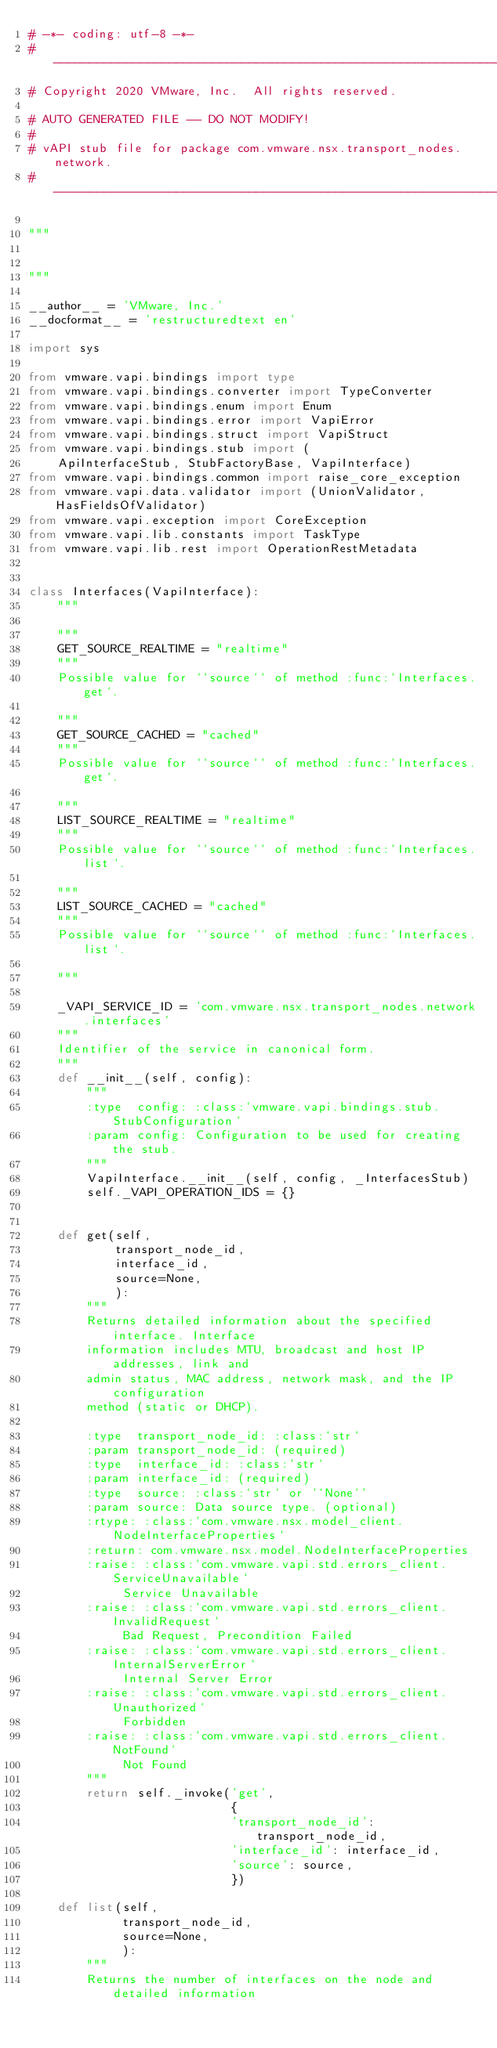<code> <loc_0><loc_0><loc_500><loc_500><_Python_># -*- coding: utf-8 -*-
#---------------------------------------------------------------------------
# Copyright 2020 VMware, Inc.  All rights reserved.

# AUTO GENERATED FILE -- DO NOT MODIFY!
#
# vAPI stub file for package com.vmware.nsx.transport_nodes.network.
#---------------------------------------------------------------------------

"""


"""

__author__ = 'VMware, Inc.'
__docformat__ = 'restructuredtext en'

import sys

from vmware.vapi.bindings import type
from vmware.vapi.bindings.converter import TypeConverter
from vmware.vapi.bindings.enum import Enum
from vmware.vapi.bindings.error import VapiError
from vmware.vapi.bindings.struct import VapiStruct
from vmware.vapi.bindings.stub import (
    ApiInterfaceStub, StubFactoryBase, VapiInterface)
from vmware.vapi.bindings.common import raise_core_exception
from vmware.vapi.data.validator import (UnionValidator, HasFieldsOfValidator)
from vmware.vapi.exception import CoreException
from vmware.vapi.lib.constants import TaskType
from vmware.vapi.lib.rest import OperationRestMetadata


class Interfaces(VapiInterface):
    """
    
    """
    GET_SOURCE_REALTIME = "realtime"
    """
    Possible value for ``source`` of method :func:`Interfaces.get`.

    """
    GET_SOURCE_CACHED = "cached"
    """
    Possible value for ``source`` of method :func:`Interfaces.get`.

    """
    LIST_SOURCE_REALTIME = "realtime"
    """
    Possible value for ``source`` of method :func:`Interfaces.list`.

    """
    LIST_SOURCE_CACHED = "cached"
    """
    Possible value for ``source`` of method :func:`Interfaces.list`.

    """

    _VAPI_SERVICE_ID = 'com.vmware.nsx.transport_nodes.network.interfaces'
    """
    Identifier of the service in canonical form.
    """
    def __init__(self, config):
        """
        :type  config: :class:`vmware.vapi.bindings.stub.StubConfiguration`
        :param config: Configuration to be used for creating the stub.
        """
        VapiInterface.__init__(self, config, _InterfacesStub)
        self._VAPI_OPERATION_IDS = {}


    def get(self,
            transport_node_id,
            interface_id,
            source=None,
            ):
        """
        Returns detailed information about the specified interface. Interface
        information includes MTU, broadcast and host IP addresses, link and
        admin status, MAC address, network mask, and the IP configuration
        method (static or DHCP).

        :type  transport_node_id: :class:`str`
        :param transport_node_id: (required)
        :type  interface_id: :class:`str`
        :param interface_id: (required)
        :type  source: :class:`str` or ``None``
        :param source: Data source type. (optional)
        :rtype: :class:`com.vmware.nsx.model_client.NodeInterfaceProperties`
        :return: com.vmware.nsx.model.NodeInterfaceProperties
        :raise: :class:`com.vmware.vapi.std.errors_client.ServiceUnavailable` 
             Service Unavailable
        :raise: :class:`com.vmware.vapi.std.errors_client.InvalidRequest` 
             Bad Request, Precondition Failed
        :raise: :class:`com.vmware.vapi.std.errors_client.InternalServerError` 
             Internal Server Error
        :raise: :class:`com.vmware.vapi.std.errors_client.Unauthorized` 
             Forbidden
        :raise: :class:`com.vmware.vapi.std.errors_client.NotFound` 
             Not Found
        """
        return self._invoke('get',
                            {
                            'transport_node_id': transport_node_id,
                            'interface_id': interface_id,
                            'source': source,
                            })

    def list(self,
             transport_node_id,
             source=None,
             ):
        """
        Returns the number of interfaces on the node and detailed information</code> 